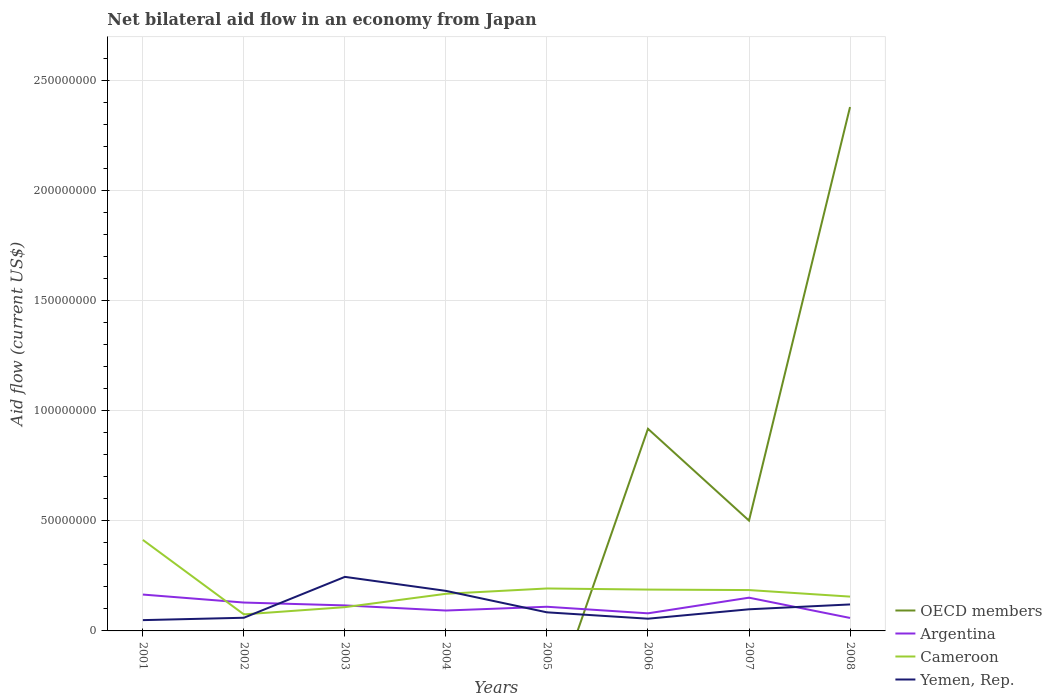How many different coloured lines are there?
Your answer should be very brief. 4. Does the line corresponding to Argentina intersect with the line corresponding to Cameroon?
Make the answer very short. Yes. Across all years, what is the maximum net bilateral aid flow in Cameroon?
Your answer should be compact. 7.51e+06. What is the total net bilateral aid flow in Yemen, Rep. in the graph?
Provide a succinct answer. 2.89e+06. What is the difference between the highest and the second highest net bilateral aid flow in Cameroon?
Your answer should be compact. 3.38e+07. What is the difference between the highest and the lowest net bilateral aid flow in Yemen, Rep.?
Offer a terse response. 3. How many lines are there?
Offer a terse response. 4. How many years are there in the graph?
Give a very brief answer. 8. What is the difference between two consecutive major ticks on the Y-axis?
Provide a short and direct response. 5.00e+07. Does the graph contain grids?
Make the answer very short. Yes. Where does the legend appear in the graph?
Offer a very short reply. Bottom right. How many legend labels are there?
Your response must be concise. 4. What is the title of the graph?
Keep it short and to the point. Net bilateral aid flow in an economy from Japan. What is the label or title of the X-axis?
Provide a succinct answer. Years. What is the label or title of the Y-axis?
Your answer should be compact. Aid flow (current US$). What is the Aid flow (current US$) of Argentina in 2001?
Your response must be concise. 1.65e+07. What is the Aid flow (current US$) in Cameroon in 2001?
Give a very brief answer. 4.13e+07. What is the Aid flow (current US$) of Yemen, Rep. in 2001?
Your answer should be very brief. 4.90e+06. What is the Aid flow (current US$) of Argentina in 2002?
Provide a succinct answer. 1.29e+07. What is the Aid flow (current US$) in Cameroon in 2002?
Make the answer very short. 7.51e+06. What is the Aid flow (current US$) of Yemen, Rep. in 2002?
Give a very brief answer. 5.98e+06. What is the Aid flow (current US$) in Argentina in 2003?
Provide a succinct answer. 1.16e+07. What is the Aid flow (current US$) of Cameroon in 2003?
Your response must be concise. 1.08e+07. What is the Aid flow (current US$) of Yemen, Rep. in 2003?
Your response must be concise. 2.45e+07. What is the Aid flow (current US$) of Argentina in 2004?
Your answer should be compact. 9.26e+06. What is the Aid flow (current US$) of Cameroon in 2004?
Keep it short and to the point. 1.69e+07. What is the Aid flow (current US$) of Yemen, Rep. in 2004?
Provide a succinct answer. 1.82e+07. What is the Aid flow (current US$) in Argentina in 2005?
Keep it short and to the point. 1.10e+07. What is the Aid flow (current US$) in Cameroon in 2005?
Provide a short and direct response. 1.93e+07. What is the Aid flow (current US$) of Yemen, Rep. in 2005?
Keep it short and to the point. 8.44e+06. What is the Aid flow (current US$) of OECD members in 2006?
Give a very brief answer. 9.18e+07. What is the Aid flow (current US$) in Argentina in 2006?
Your response must be concise. 7.99e+06. What is the Aid flow (current US$) of Cameroon in 2006?
Offer a very short reply. 1.88e+07. What is the Aid flow (current US$) in Yemen, Rep. in 2006?
Your response must be concise. 5.55e+06. What is the Aid flow (current US$) in OECD members in 2007?
Offer a terse response. 5.01e+07. What is the Aid flow (current US$) of Argentina in 2007?
Offer a terse response. 1.51e+07. What is the Aid flow (current US$) in Cameroon in 2007?
Ensure brevity in your answer.  1.86e+07. What is the Aid flow (current US$) of Yemen, Rep. in 2007?
Your response must be concise. 9.82e+06. What is the Aid flow (current US$) in OECD members in 2008?
Make the answer very short. 2.38e+08. What is the Aid flow (current US$) in Argentina in 2008?
Your answer should be compact. 5.89e+06. What is the Aid flow (current US$) of Cameroon in 2008?
Offer a terse response. 1.56e+07. What is the Aid flow (current US$) of Yemen, Rep. in 2008?
Keep it short and to the point. 1.20e+07. Across all years, what is the maximum Aid flow (current US$) of OECD members?
Your answer should be compact. 2.38e+08. Across all years, what is the maximum Aid flow (current US$) of Argentina?
Offer a very short reply. 1.65e+07. Across all years, what is the maximum Aid flow (current US$) in Cameroon?
Your response must be concise. 4.13e+07. Across all years, what is the maximum Aid flow (current US$) in Yemen, Rep.?
Make the answer very short. 2.45e+07. Across all years, what is the minimum Aid flow (current US$) of Argentina?
Give a very brief answer. 5.89e+06. Across all years, what is the minimum Aid flow (current US$) in Cameroon?
Your response must be concise. 7.51e+06. Across all years, what is the minimum Aid flow (current US$) in Yemen, Rep.?
Your answer should be compact. 4.90e+06. What is the total Aid flow (current US$) of OECD members in the graph?
Offer a very short reply. 3.80e+08. What is the total Aid flow (current US$) of Argentina in the graph?
Your answer should be compact. 9.02e+07. What is the total Aid flow (current US$) of Cameroon in the graph?
Offer a very short reply. 1.49e+08. What is the total Aid flow (current US$) in Yemen, Rep. in the graph?
Your answer should be compact. 8.94e+07. What is the difference between the Aid flow (current US$) in Argentina in 2001 and that in 2002?
Give a very brief answer. 3.63e+06. What is the difference between the Aid flow (current US$) in Cameroon in 2001 and that in 2002?
Your answer should be very brief. 3.38e+07. What is the difference between the Aid flow (current US$) of Yemen, Rep. in 2001 and that in 2002?
Your response must be concise. -1.08e+06. What is the difference between the Aid flow (current US$) in Argentina in 2001 and that in 2003?
Your answer should be compact. 4.93e+06. What is the difference between the Aid flow (current US$) in Cameroon in 2001 and that in 2003?
Provide a short and direct response. 3.05e+07. What is the difference between the Aid flow (current US$) of Yemen, Rep. in 2001 and that in 2003?
Provide a succinct answer. -1.96e+07. What is the difference between the Aid flow (current US$) of Argentina in 2001 and that in 2004?
Offer a terse response. 7.25e+06. What is the difference between the Aid flow (current US$) in Cameroon in 2001 and that in 2004?
Offer a very short reply. 2.45e+07. What is the difference between the Aid flow (current US$) in Yemen, Rep. in 2001 and that in 2004?
Offer a very short reply. -1.33e+07. What is the difference between the Aid flow (current US$) of Argentina in 2001 and that in 2005?
Make the answer very short. 5.54e+06. What is the difference between the Aid flow (current US$) in Cameroon in 2001 and that in 2005?
Provide a short and direct response. 2.20e+07. What is the difference between the Aid flow (current US$) in Yemen, Rep. in 2001 and that in 2005?
Offer a terse response. -3.54e+06. What is the difference between the Aid flow (current US$) of Argentina in 2001 and that in 2006?
Keep it short and to the point. 8.52e+06. What is the difference between the Aid flow (current US$) of Cameroon in 2001 and that in 2006?
Give a very brief answer. 2.26e+07. What is the difference between the Aid flow (current US$) of Yemen, Rep. in 2001 and that in 2006?
Your answer should be compact. -6.50e+05. What is the difference between the Aid flow (current US$) in Argentina in 2001 and that in 2007?
Ensure brevity in your answer.  1.42e+06. What is the difference between the Aid flow (current US$) of Cameroon in 2001 and that in 2007?
Keep it short and to the point. 2.28e+07. What is the difference between the Aid flow (current US$) in Yemen, Rep. in 2001 and that in 2007?
Offer a terse response. -4.92e+06. What is the difference between the Aid flow (current US$) in Argentina in 2001 and that in 2008?
Provide a succinct answer. 1.06e+07. What is the difference between the Aid flow (current US$) in Cameroon in 2001 and that in 2008?
Your answer should be compact. 2.57e+07. What is the difference between the Aid flow (current US$) of Yemen, Rep. in 2001 and that in 2008?
Ensure brevity in your answer.  -7.12e+06. What is the difference between the Aid flow (current US$) in Argentina in 2002 and that in 2003?
Offer a terse response. 1.30e+06. What is the difference between the Aid flow (current US$) in Cameroon in 2002 and that in 2003?
Make the answer very short. -3.28e+06. What is the difference between the Aid flow (current US$) in Yemen, Rep. in 2002 and that in 2003?
Keep it short and to the point. -1.86e+07. What is the difference between the Aid flow (current US$) in Argentina in 2002 and that in 2004?
Your answer should be compact. 3.62e+06. What is the difference between the Aid flow (current US$) in Cameroon in 2002 and that in 2004?
Keep it short and to the point. -9.35e+06. What is the difference between the Aid flow (current US$) of Yemen, Rep. in 2002 and that in 2004?
Ensure brevity in your answer.  -1.22e+07. What is the difference between the Aid flow (current US$) of Argentina in 2002 and that in 2005?
Give a very brief answer. 1.91e+06. What is the difference between the Aid flow (current US$) of Cameroon in 2002 and that in 2005?
Ensure brevity in your answer.  -1.18e+07. What is the difference between the Aid flow (current US$) of Yemen, Rep. in 2002 and that in 2005?
Your answer should be compact. -2.46e+06. What is the difference between the Aid flow (current US$) in Argentina in 2002 and that in 2006?
Provide a short and direct response. 4.89e+06. What is the difference between the Aid flow (current US$) of Cameroon in 2002 and that in 2006?
Keep it short and to the point. -1.13e+07. What is the difference between the Aid flow (current US$) of Yemen, Rep. in 2002 and that in 2006?
Your answer should be very brief. 4.30e+05. What is the difference between the Aid flow (current US$) of Argentina in 2002 and that in 2007?
Make the answer very short. -2.21e+06. What is the difference between the Aid flow (current US$) of Cameroon in 2002 and that in 2007?
Offer a terse response. -1.10e+07. What is the difference between the Aid flow (current US$) of Yemen, Rep. in 2002 and that in 2007?
Provide a short and direct response. -3.84e+06. What is the difference between the Aid flow (current US$) of Argentina in 2002 and that in 2008?
Make the answer very short. 6.99e+06. What is the difference between the Aid flow (current US$) of Cameroon in 2002 and that in 2008?
Give a very brief answer. -8.07e+06. What is the difference between the Aid flow (current US$) in Yemen, Rep. in 2002 and that in 2008?
Give a very brief answer. -6.04e+06. What is the difference between the Aid flow (current US$) in Argentina in 2003 and that in 2004?
Provide a succinct answer. 2.32e+06. What is the difference between the Aid flow (current US$) in Cameroon in 2003 and that in 2004?
Your answer should be very brief. -6.07e+06. What is the difference between the Aid flow (current US$) in Yemen, Rep. in 2003 and that in 2004?
Offer a very short reply. 6.36e+06. What is the difference between the Aid flow (current US$) in Argentina in 2003 and that in 2005?
Keep it short and to the point. 6.10e+05. What is the difference between the Aid flow (current US$) of Cameroon in 2003 and that in 2005?
Provide a short and direct response. -8.48e+06. What is the difference between the Aid flow (current US$) in Yemen, Rep. in 2003 and that in 2005?
Your answer should be compact. 1.61e+07. What is the difference between the Aid flow (current US$) of Argentina in 2003 and that in 2006?
Your response must be concise. 3.59e+06. What is the difference between the Aid flow (current US$) of Cameroon in 2003 and that in 2006?
Your response must be concise. -7.98e+06. What is the difference between the Aid flow (current US$) in Yemen, Rep. in 2003 and that in 2006?
Your response must be concise. 1.90e+07. What is the difference between the Aid flow (current US$) of Argentina in 2003 and that in 2007?
Offer a terse response. -3.51e+06. What is the difference between the Aid flow (current US$) in Cameroon in 2003 and that in 2007?
Provide a succinct answer. -7.76e+06. What is the difference between the Aid flow (current US$) of Yemen, Rep. in 2003 and that in 2007?
Offer a very short reply. 1.47e+07. What is the difference between the Aid flow (current US$) of Argentina in 2003 and that in 2008?
Offer a terse response. 5.69e+06. What is the difference between the Aid flow (current US$) in Cameroon in 2003 and that in 2008?
Your response must be concise. -4.79e+06. What is the difference between the Aid flow (current US$) of Yemen, Rep. in 2003 and that in 2008?
Ensure brevity in your answer.  1.25e+07. What is the difference between the Aid flow (current US$) of Argentina in 2004 and that in 2005?
Provide a short and direct response. -1.71e+06. What is the difference between the Aid flow (current US$) of Cameroon in 2004 and that in 2005?
Your answer should be compact. -2.41e+06. What is the difference between the Aid flow (current US$) of Yemen, Rep. in 2004 and that in 2005?
Ensure brevity in your answer.  9.74e+06. What is the difference between the Aid flow (current US$) in Argentina in 2004 and that in 2006?
Offer a terse response. 1.27e+06. What is the difference between the Aid flow (current US$) of Cameroon in 2004 and that in 2006?
Make the answer very short. -1.91e+06. What is the difference between the Aid flow (current US$) of Yemen, Rep. in 2004 and that in 2006?
Keep it short and to the point. 1.26e+07. What is the difference between the Aid flow (current US$) in Argentina in 2004 and that in 2007?
Your response must be concise. -5.83e+06. What is the difference between the Aid flow (current US$) of Cameroon in 2004 and that in 2007?
Make the answer very short. -1.69e+06. What is the difference between the Aid flow (current US$) in Yemen, Rep. in 2004 and that in 2007?
Give a very brief answer. 8.36e+06. What is the difference between the Aid flow (current US$) of Argentina in 2004 and that in 2008?
Offer a very short reply. 3.37e+06. What is the difference between the Aid flow (current US$) of Cameroon in 2004 and that in 2008?
Make the answer very short. 1.28e+06. What is the difference between the Aid flow (current US$) in Yemen, Rep. in 2004 and that in 2008?
Offer a very short reply. 6.16e+06. What is the difference between the Aid flow (current US$) of Argentina in 2005 and that in 2006?
Your response must be concise. 2.98e+06. What is the difference between the Aid flow (current US$) in Yemen, Rep. in 2005 and that in 2006?
Offer a very short reply. 2.89e+06. What is the difference between the Aid flow (current US$) of Argentina in 2005 and that in 2007?
Make the answer very short. -4.12e+06. What is the difference between the Aid flow (current US$) of Cameroon in 2005 and that in 2007?
Ensure brevity in your answer.  7.20e+05. What is the difference between the Aid flow (current US$) in Yemen, Rep. in 2005 and that in 2007?
Offer a very short reply. -1.38e+06. What is the difference between the Aid flow (current US$) in Argentina in 2005 and that in 2008?
Make the answer very short. 5.08e+06. What is the difference between the Aid flow (current US$) of Cameroon in 2005 and that in 2008?
Your response must be concise. 3.69e+06. What is the difference between the Aid flow (current US$) in Yemen, Rep. in 2005 and that in 2008?
Make the answer very short. -3.58e+06. What is the difference between the Aid flow (current US$) of OECD members in 2006 and that in 2007?
Ensure brevity in your answer.  4.17e+07. What is the difference between the Aid flow (current US$) in Argentina in 2006 and that in 2007?
Ensure brevity in your answer.  -7.10e+06. What is the difference between the Aid flow (current US$) of Cameroon in 2006 and that in 2007?
Make the answer very short. 2.20e+05. What is the difference between the Aid flow (current US$) in Yemen, Rep. in 2006 and that in 2007?
Make the answer very short. -4.27e+06. What is the difference between the Aid flow (current US$) of OECD members in 2006 and that in 2008?
Give a very brief answer. -1.46e+08. What is the difference between the Aid flow (current US$) of Argentina in 2006 and that in 2008?
Your answer should be very brief. 2.10e+06. What is the difference between the Aid flow (current US$) in Cameroon in 2006 and that in 2008?
Your response must be concise. 3.19e+06. What is the difference between the Aid flow (current US$) of Yemen, Rep. in 2006 and that in 2008?
Your answer should be very brief. -6.47e+06. What is the difference between the Aid flow (current US$) of OECD members in 2007 and that in 2008?
Offer a very short reply. -1.88e+08. What is the difference between the Aid flow (current US$) of Argentina in 2007 and that in 2008?
Provide a succinct answer. 9.20e+06. What is the difference between the Aid flow (current US$) in Cameroon in 2007 and that in 2008?
Offer a very short reply. 2.97e+06. What is the difference between the Aid flow (current US$) in Yemen, Rep. in 2007 and that in 2008?
Provide a succinct answer. -2.20e+06. What is the difference between the Aid flow (current US$) in Argentina in 2001 and the Aid flow (current US$) in Cameroon in 2002?
Offer a very short reply. 9.00e+06. What is the difference between the Aid flow (current US$) of Argentina in 2001 and the Aid flow (current US$) of Yemen, Rep. in 2002?
Your response must be concise. 1.05e+07. What is the difference between the Aid flow (current US$) of Cameroon in 2001 and the Aid flow (current US$) of Yemen, Rep. in 2002?
Offer a terse response. 3.53e+07. What is the difference between the Aid flow (current US$) of Argentina in 2001 and the Aid flow (current US$) of Cameroon in 2003?
Ensure brevity in your answer.  5.72e+06. What is the difference between the Aid flow (current US$) in Argentina in 2001 and the Aid flow (current US$) in Yemen, Rep. in 2003?
Keep it short and to the point. -8.03e+06. What is the difference between the Aid flow (current US$) of Cameroon in 2001 and the Aid flow (current US$) of Yemen, Rep. in 2003?
Your response must be concise. 1.68e+07. What is the difference between the Aid flow (current US$) in Argentina in 2001 and the Aid flow (current US$) in Cameroon in 2004?
Offer a very short reply. -3.50e+05. What is the difference between the Aid flow (current US$) in Argentina in 2001 and the Aid flow (current US$) in Yemen, Rep. in 2004?
Your response must be concise. -1.67e+06. What is the difference between the Aid flow (current US$) of Cameroon in 2001 and the Aid flow (current US$) of Yemen, Rep. in 2004?
Your answer should be very brief. 2.31e+07. What is the difference between the Aid flow (current US$) in Argentina in 2001 and the Aid flow (current US$) in Cameroon in 2005?
Your response must be concise. -2.76e+06. What is the difference between the Aid flow (current US$) in Argentina in 2001 and the Aid flow (current US$) in Yemen, Rep. in 2005?
Offer a terse response. 8.07e+06. What is the difference between the Aid flow (current US$) of Cameroon in 2001 and the Aid flow (current US$) of Yemen, Rep. in 2005?
Your response must be concise. 3.29e+07. What is the difference between the Aid flow (current US$) in Argentina in 2001 and the Aid flow (current US$) in Cameroon in 2006?
Ensure brevity in your answer.  -2.26e+06. What is the difference between the Aid flow (current US$) of Argentina in 2001 and the Aid flow (current US$) of Yemen, Rep. in 2006?
Ensure brevity in your answer.  1.10e+07. What is the difference between the Aid flow (current US$) of Cameroon in 2001 and the Aid flow (current US$) of Yemen, Rep. in 2006?
Offer a very short reply. 3.58e+07. What is the difference between the Aid flow (current US$) of Argentina in 2001 and the Aid flow (current US$) of Cameroon in 2007?
Give a very brief answer. -2.04e+06. What is the difference between the Aid flow (current US$) of Argentina in 2001 and the Aid flow (current US$) of Yemen, Rep. in 2007?
Offer a terse response. 6.69e+06. What is the difference between the Aid flow (current US$) in Cameroon in 2001 and the Aid flow (current US$) in Yemen, Rep. in 2007?
Offer a terse response. 3.15e+07. What is the difference between the Aid flow (current US$) in Argentina in 2001 and the Aid flow (current US$) in Cameroon in 2008?
Provide a short and direct response. 9.30e+05. What is the difference between the Aid flow (current US$) of Argentina in 2001 and the Aid flow (current US$) of Yemen, Rep. in 2008?
Provide a succinct answer. 4.49e+06. What is the difference between the Aid flow (current US$) of Cameroon in 2001 and the Aid flow (current US$) of Yemen, Rep. in 2008?
Your response must be concise. 2.93e+07. What is the difference between the Aid flow (current US$) in Argentina in 2002 and the Aid flow (current US$) in Cameroon in 2003?
Give a very brief answer. 2.09e+06. What is the difference between the Aid flow (current US$) of Argentina in 2002 and the Aid flow (current US$) of Yemen, Rep. in 2003?
Provide a succinct answer. -1.17e+07. What is the difference between the Aid flow (current US$) in Cameroon in 2002 and the Aid flow (current US$) in Yemen, Rep. in 2003?
Provide a succinct answer. -1.70e+07. What is the difference between the Aid flow (current US$) in Argentina in 2002 and the Aid flow (current US$) in Cameroon in 2004?
Your response must be concise. -3.98e+06. What is the difference between the Aid flow (current US$) of Argentina in 2002 and the Aid flow (current US$) of Yemen, Rep. in 2004?
Ensure brevity in your answer.  -5.30e+06. What is the difference between the Aid flow (current US$) of Cameroon in 2002 and the Aid flow (current US$) of Yemen, Rep. in 2004?
Provide a succinct answer. -1.07e+07. What is the difference between the Aid flow (current US$) in Argentina in 2002 and the Aid flow (current US$) in Cameroon in 2005?
Your response must be concise. -6.39e+06. What is the difference between the Aid flow (current US$) of Argentina in 2002 and the Aid flow (current US$) of Yemen, Rep. in 2005?
Offer a terse response. 4.44e+06. What is the difference between the Aid flow (current US$) of Cameroon in 2002 and the Aid flow (current US$) of Yemen, Rep. in 2005?
Ensure brevity in your answer.  -9.30e+05. What is the difference between the Aid flow (current US$) of Argentina in 2002 and the Aid flow (current US$) of Cameroon in 2006?
Your answer should be very brief. -5.89e+06. What is the difference between the Aid flow (current US$) in Argentina in 2002 and the Aid flow (current US$) in Yemen, Rep. in 2006?
Provide a succinct answer. 7.33e+06. What is the difference between the Aid flow (current US$) of Cameroon in 2002 and the Aid flow (current US$) of Yemen, Rep. in 2006?
Make the answer very short. 1.96e+06. What is the difference between the Aid flow (current US$) in Argentina in 2002 and the Aid flow (current US$) in Cameroon in 2007?
Provide a short and direct response. -5.67e+06. What is the difference between the Aid flow (current US$) in Argentina in 2002 and the Aid flow (current US$) in Yemen, Rep. in 2007?
Offer a terse response. 3.06e+06. What is the difference between the Aid flow (current US$) in Cameroon in 2002 and the Aid flow (current US$) in Yemen, Rep. in 2007?
Ensure brevity in your answer.  -2.31e+06. What is the difference between the Aid flow (current US$) of Argentina in 2002 and the Aid flow (current US$) of Cameroon in 2008?
Give a very brief answer. -2.70e+06. What is the difference between the Aid flow (current US$) of Argentina in 2002 and the Aid flow (current US$) of Yemen, Rep. in 2008?
Give a very brief answer. 8.60e+05. What is the difference between the Aid flow (current US$) in Cameroon in 2002 and the Aid flow (current US$) in Yemen, Rep. in 2008?
Provide a short and direct response. -4.51e+06. What is the difference between the Aid flow (current US$) of Argentina in 2003 and the Aid flow (current US$) of Cameroon in 2004?
Provide a short and direct response. -5.28e+06. What is the difference between the Aid flow (current US$) of Argentina in 2003 and the Aid flow (current US$) of Yemen, Rep. in 2004?
Provide a short and direct response. -6.60e+06. What is the difference between the Aid flow (current US$) in Cameroon in 2003 and the Aid flow (current US$) in Yemen, Rep. in 2004?
Provide a succinct answer. -7.39e+06. What is the difference between the Aid flow (current US$) of Argentina in 2003 and the Aid flow (current US$) of Cameroon in 2005?
Make the answer very short. -7.69e+06. What is the difference between the Aid flow (current US$) in Argentina in 2003 and the Aid flow (current US$) in Yemen, Rep. in 2005?
Ensure brevity in your answer.  3.14e+06. What is the difference between the Aid flow (current US$) in Cameroon in 2003 and the Aid flow (current US$) in Yemen, Rep. in 2005?
Your answer should be very brief. 2.35e+06. What is the difference between the Aid flow (current US$) in Argentina in 2003 and the Aid flow (current US$) in Cameroon in 2006?
Ensure brevity in your answer.  -7.19e+06. What is the difference between the Aid flow (current US$) in Argentina in 2003 and the Aid flow (current US$) in Yemen, Rep. in 2006?
Give a very brief answer. 6.03e+06. What is the difference between the Aid flow (current US$) in Cameroon in 2003 and the Aid flow (current US$) in Yemen, Rep. in 2006?
Ensure brevity in your answer.  5.24e+06. What is the difference between the Aid flow (current US$) of Argentina in 2003 and the Aid flow (current US$) of Cameroon in 2007?
Ensure brevity in your answer.  -6.97e+06. What is the difference between the Aid flow (current US$) in Argentina in 2003 and the Aid flow (current US$) in Yemen, Rep. in 2007?
Ensure brevity in your answer.  1.76e+06. What is the difference between the Aid flow (current US$) in Cameroon in 2003 and the Aid flow (current US$) in Yemen, Rep. in 2007?
Offer a very short reply. 9.70e+05. What is the difference between the Aid flow (current US$) in Argentina in 2003 and the Aid flow (current US$) in Cameroon in 2008?
Provide a short and direct response. -4.00e+06. What is the difference between the Aid flow (current US$) in Argentina in 2003 and the Aid flow (current US$) in Yemen, Rep. in 2008?
Provide a short and direct response. -4.40e+05. What is the difference between the Aid flow (current US$) of Cameroon in 2003 and the Aid flow (current US$) of Yemen, Rep. in 2008?
Ensure brevity in your answer.  -1.23e+06. What is the difference between the Aid flow (current US$) of Argentina in 2004 and the Aid flow (current US$) of Cameroon in 2005?
Your response must be concise. -1.00e+07. What is the difference between the Aid flow (current US$) in Argentina in 2004 and the Aid flow (current US$) in Yemen, Rep. in 2005?
Ensure brevity in your answer.  8.20e+05. What is the difference between the Aid flow (current US$) in Cameroon in 2004 and the Aid flow (current US$) in Yemen, Rep. in 2005?
Your answer should be compact. 8.42e+06. What is the difference between the Aid flow (current US$) in Argentina in 2004 and the Aid flow (current US$) in Cameroon in 2006?
Offer a very short reply. -9.51e+06. What is the difference between the Aid flow (current US$) of Argentina in 2004 and the Aid flow (current US$) of Yemen, Rep. in 2006?
Your answer should be compact. 3.71e+06. What is the difference between the Aid flow (current US$) in Cameroon in 2004 and the Aid flow (current US$) in Yemen, Rep. in 2006?
Offer a very short reply. 1.13e+07. What is the difference between the Aid flow (current US$) of Argentina in 2004 and the Aid flow (current US$) of Cameroon in 2007?
Offer a very short reply. -9.29e+06. What is the difference between the Aid flow (current US$) in Argentina in 2004 and the Aid flow (current US$) in Yemen, Rep. in 2007?
Your answer should be very brief. -5.60e+05. What is the difference between the Aid flow (current US$) of Cameroon in 2004 and the Aid flow (current US$) of Yemen, Rep. in 2007?
Give a very brief answer. 7.04e+06. What is the difference between the Aid flow (current US$) in Argentina in 2004 and the Aid flow (current US$) in Cameroon in 2008?
Your answer should be very brief. -6.32e+06. What is the difference between the Aid flow (current US$) of Argentina in 2004 and the Aid flow (current US$) of Yemen, Rep. in 2008?
Provide a short and direct response. -2.76e+06. What is the difference between the Aid flow (current US$) in Cameroon in 2004 and the Aid flow (current US$) in Yemen, Rep. in 2008?
Ensure brevity in your answer.  4.84e+06. What is the difference between the Aid flow (current US$) of Argentina in 2005 and the Aid flow (current US$) of Cameroon in 2006?
Your answer should be very brief. -7.80e+06. What is the difference between the Aid flow (current US$) of Argentina in 2005 and the Aid flow (current US$) of Yemen, Rep. in 2006?
Provide a succinct answer. 5.42e+06. What is the difference between the Aid flow (current US$) in Cameroon in 2005 and the Aid flow (current US$) in Yemen, Rep. in 2006?
Ensure brevity in your answer.  1.37e+07. What is the difference between the Aid flow (current US$) in Argentina in 2005 and the Aid flow (current US$) in Cameroon in 2007?
Provide a succinct answer. -7.58e+06. What is the difference between the Aid flow (current US$) of Argentina in 2005 and the Aid flow (current US$) of Yemen, Rep. in 2007?
Offer a very short reply. 1.15e+06. What is the difference between the Aid flow (current US$) of Cameroon in 2005 and the Aid flow (current US$) of Yemen, Rep. in 2007?
Your answer should be very brief. 9.45e+06. What is the difference between the Aid flow (current US$) in Argentina in 2005 and the Aid flow (current US$) in Cameroon in 2008?
Make the answer very short. -4.61e+06. What is the difference between the Aid flow (current US$) of Argentina in 2005 and the Aid flow (current US$) of Yemen, Rep. in 2008?
Give a very brief answer. -1.05e+06. What is the difference between the Aid flow (current US$) of Cameroon in 2005 and the Aid flow (current US$) of Yemen, Rep. in 2008?
Offer a very short reply. 7.25e+06. What is the difference between the Aid flow (current US$) in OECD members in 2006 and the Aid flow (current US$) in Argentina in 2007?
Provide a short and direct response. 7.67e+07. What is the difference between the Aid flow (current US$) of OECD members in 2006 and the Aid flow (current US$) of Cameroon in 2007?
Give a very brief answer. 7.32e+07. What is the difference between the Aid flow (current US$) of OECD members in 2006 and the Aid flow (current US$) of Yemen, Rep. in 2007?
Your response must be concise. 8.19e+07. What is the difference between the Aid flow (current US$) of Argentina in 2006 and the Aid flow (current US$) of Cameroon in 2007?
Offer a very short reply. -1.06e+07. What is the difference between the Aid flow (current US$) in Argentina in 2006 and the Aid flow (current US$) in Yemen, Rep. in 2007?
Give a very brief answer. -1.83e+06. What is the difference between the Aid flow (current US$) in Cameroon in 2006 and the Aid flow (current US$) in Yemen, Rep. in 2007?
Keep it short and to the point. 8.95e+06. What is the difference between the Aid flow (current US$) in OECD members in 2006 and the Aid flow (current US$) in Argentina in 2008?
Make the answer very short. 8.59e+07. What is the difference between the Aid flow (current US$) in OECD members in 2006 and the Aid flow (current US$) in Cameroon in 2008?
Ensure brevity in your answer.  7.62e+07. What is the difference between the Aid flow (current US$) of OECD members in 2006 and the Aid flow (current US$) of Yemen, Rep. in 2008?
Give a very brief answer. 7.97e+07. What is the difference between the Aid flow (current US$) of Argentina in 2006 and the Aid flow (current US$) of Cameroon in 2008?
Give a very brief answer. -7.59e+06. What is the difference between the Aid flow (current US$) of Argentina in 2006 and the Aid flow (current US$) of Yemen, Rep. in 2008?
Your answer should be compact. -4.03e+06. What is the difference between the Aid flow (current US$) in Cameroon in 2006 and the Aid flow (current US$) in Yemen, Rep. in 2008?
Make the answer very short. 6.75e+06. What is the difference between the Aid flow (current US$) in OECD members in 2007 and the Aid flow (current US$) in Argentina in 2008?
Give a very brief answer. 4.42e+07. What is the difference between the Aid flow (current US$) of OECD members in 2007 and the Aid flow (current US$) of Cameroon in 2008?
Give a very brief answer. 3.45e+07. What is the difference between the Aid flow (current US$) in OECD members in 2007 and the Aid flow (current US$) in Yemen, Rep. in 2008?
Make the answer very short. 3.81e+07. What is the difference between the Aid flow (current US$) in Argentina in 2007 and the Aid flow (current US$) in Cameroon in 2008?
Make the answer very short. -4.90e+05. What is the difference between the Aid flow (current US$) of Argentina in 2007 and the Aid flow (current US$) of Yemen, Rep. in 2008?
Provide a short and direct response. 3.07e+06. What is the difference between the Aid flow (current US$) in Cameroon in 2007 and the Aid flow (current US$) in Yemen, Rep. in 2008?
Provide a short and direct response. 6.53e+06. What is the average Aid flow (current US$) of OECD members per year?
Your answer should be very brief. 4.75e+07. What is the average Aid flow (current US$) in Argentina per year?
Your answer should be compact. 1.13e+07. What is the average Aid flow (current US$) of Cameroon per year?
Offer a very short reply. 1.86e+07. What is the average Aid flow (current US$) of Yemen, Rep. per year?
Give a very brief answer. 1.12e+07. In the year 2001, what is the difference between the Aid flow (current US$) of Argentina and Aid flow (current US$) of Cameroon?
Offer a very short reply. -2.48e+07. In the year 2001, what is the difference between the Aid flow (current US$) of Argentina and Aid flow (current US$) of Yemen, Rep.?
Your response must be concise. 1.16e+07. In the year 2001, what is the difference between the Aid flow (current US$) in Cameroon and Aid flow (current US$) in Yemen, Rep.?
Ensure brevity in your answer.  3.64e+07. In the year 2002, what is the difference between the Aid flow (current US$) of Argentina and Aid flow (current US$) of Cameroon?
Make the answer very short. 5.37e+06. In the year 2002, what is the difference between the Aid flow (current US$) of Argentina and Aid flow (current US$) of Yemen, Rep.?
Offer a very short reply. 6.90e+06. In the year 2002, what is the difference between the Aid flow (current US$) in Cameroon and Aid flow (current US$) in Yemen, Rep.?
Offer a terse response. 1.53e+06. In the year 2003, what is the difference between the Aid flow (current US$) of Argentina and Aid flow (current US$) of Cameroon?
Provide a short and direct response. 7.90e+05. In the year 2003, what is the difference between the Aid flow (current US$) of Argentina and Aid flow (current US$) of Yemen, Rep.?
Provide a short and direct response. -1.30e+07. In the year 2003, what is the difference between the Aid flow (current US$) of Cameroon and Aid flow (current US$) of Yemen, Rep.?
Keep it short and to the point. -1.38e+07. In the year 2004, what is the difference between the Aid flow (current US$) of Argentina and Aid flow (current US$) of Cameroon?
Provide a short and direct response. -7.60e+06. In the year 2004, what is the difference between the Aid flow (current US$) of Argentina and Aid flow (current US$) of Yemen, Rep.?
Provide a short and direct response. -8.92e+06. In the year 2004, what is the difference between the Aid flow (current US$) of Cameroon and Aid flow (current US$) of Yemen, Rep.?
Offer a very short reply. -1.32e+06. In the year 2005, what is the difference between the Aid flow (current US$) of Argentina and Aid flow (current US$) of Cameroon?
Keep it short and to the point. -8.30e+06. In the year 2005, what is the difference between the Aid flow (current US$) in Argentina and Aid flow (current US$) in Yemen, Rep.?
Provide a succinct answer. 2.53e+06. In the year 2005, what is the difference between the Aid flow (current US$) in Cameroon and Aid flow (current US$) in Yemen, Rep.?
Offer a very short reply. 1.08e+07. In the year 2006, what is the difference between the Aid flow (current US$) of OECD members and Aid flow (current US$) of Argentina?
Your response must be concise. 8.38e+07. In the year 2006, what is the difference between the Aid flow (current US$) of OECD members and Aid flow (current US$) of Cameroon?
Your response must be concise. 7.30e+07. In the year 2006, what is the difference between the Aid flow (current US$) in OECD members and Aid flow (current US$) in Yemen, Rep.?
Your response must be concise. 8.62e+07. In the year 2006, what is the difference between the Aid flow (current US$) of Argentina and Aid flow (current US$) of Cameroon?
Give a very brief answer. -1.08e+07. In the year 2006, what is the difference between the Aid flow (current US$) of Argentina and Aid flow (current US$) of Yemen, Rep.?
Your response must be concise. 2.44e+06. In the year 2006, what is the difference between the Aid flow (current US$) in Cameroon and Aid flow (current US$) in Yemen, Rep.?
Your answer should be very brief. 1.32e+07. In the year 2007, what is the difference between the Aid flow (current US$) in OECD members and Aid flow (current US$) in Argentina?
Make the answer very short. 3.50e+07. In the year 2007, what is the difference between the Aid flow (current US$) of OECD members and Aid flow (current US$) of Cameroon?
Make the answer very short. 3.15e+07. In the year 2007, what is the difference between the Aid flow (current US$) in OECD members and Aid flow (current US$) in Yemen, Rep.?
Provide a short and direct response. 4.03e+07. In the year 2007, what is the difference between the Aid flow (current US$) in Argentina and Aid flow (current US$) in Cameroon?
Make the answer very short. -3.46e+06. In the year 2007, what is the difference between the Aid flow (current US$) in Argentina and Aid flow (current US$) in Yemen, Rep.?
Offer a terse response. 5.27e+06. In the year 2007, what is the difference between the Aid flow (current US$) of Cameroon and Aid flow (current US$) of Yemen, Rep.?
Offer a terse response. 8.73e+06. In the year 2008, what is the difference between the Aid flow (current US$) in OECD members and Aid flow (current US$) in Argentina?
Give a very brief answer. 2.32e+08. In the year 2008, what is the difference between the Aid flow (current US$) of OECD members and Aid flow (current US$) of Cameroon?
Offer a very short reply. 2.22e+08. In the year 2008, what is the difference between the Aid flow (current US$) of OECD members and Aid flow (current US$) of Yemen, Rep.?
Provide a succinct answer. 2.26e+08. In the year 2008, what is the difference between the Aid flow (current US$) in Argentina and Aid flow (current US$) in Cameroon?
Your answer should be very brief. -9.69e+06. In the year 2008, what is the difference between the Aid flow (current US$) of Argentina and Aid flow (current US$) of Yemen, Rep.?
Your response must be concise. -6.13e+06. In the year 2008, what is the difference between the Aid flow (current US$) in Cameroon and Aid flow (current US$) in Yemen, Rep.?
Your response must be concise. 3.56e+06. What is the ratio of the Aid flow (current US$) of Argentina in 2001 to that in 2002?
Offer a very short reply. 1.28. What is the ratio of the Aid flow (current US$) in Cameroon in 2001 to that in 2002?
Make the answer very short. 5.5. What is the ratio of the Aid flow (current US$) in Yemen, Rep. in 2001 to that in 2002?
Offer a very short reply. 0.82. What is the ratio of the Aid flow (current US$) of Argentina in 2001 to that in 2003?
Your answer should be compact. 1.43. What is the ratio of the Aid flow (current US$) in Cameroon in 2001 to that in 2003?
Make the answer very short. 3.83. What is the ratio of the Aid flow (current US$) in Yemen, Rep. in 2001 to that in 2003?
Make the answer very short. 0.2. What is the ratio of the Aid flow (current US$) in Argentina in 2001 to that in 2004?
Offer a very short reply. 1.78. What is the ratio of the Aid flow (current US$) of Cameroon in 2001 to that in 2004?
Your answer should be very brief. 2.45. What is the ratio of the Aid flow (current US$) of Yemen, Rep. in 2001 to that in 2004?
Offer a very short reply. 0.27. What is the ratio of the Aid flow (current US$) of Argentina in 2001 to that in 2005?
Your response must be concise. 1.5. What is the ratio of the Aid flow (current US$) in Cameroon in 2001 to that in 2005?
Offer a terse response. 2.14. What is the ratio of the Aid flow (current US$) of Yemen, Rep. in 2001 to that in 2005?
Provide a succinct answer. 0.58. What is the ratio of the Aid flow (current US$) in Argentina in 2001 to that in 2006?
Provide a short and direct response. 2.07. What is the ratio of the Aid flow (current US$) in Cameroon in 2001 to that in 2006?
Your answer should be compact. 2.2. What is the ratio of the Aid flow (current US$) of Yemen, Rep. in 2001 to that in 2006?
Your answer should be compact. 0.88. What is the ratio of the Aid flow (current US$) of Argentina in 2001 to that in 2007?
Make the answer very short. 1.09. What is the ratio of the Aid flow (current US$) of Cameroon in 2001 to that in 2007?
Give a very brief answer. 2.23. What is the ratio of the Aid flow (current US$) of Yemen, Rep. in 2001 to that in 2007?
Your answer should be very brief. 0.5. What is the ratio of the Aid flow (current US$) in Argentina in 2001 to that in 2008?
Offer a very short reply. 2.8. What is the ratio of the Aid flow (current US$) in Cameroon in 2001 to that in 2008?
Make the answer very short. 2.65. What is the ratio of the Aid flow (current US$) of Yemen, Rep. in 2001 to that in 2008?
Offer a very short reply. 0.41. What is the ratio of the Aid flow (current US$) of Argentina in 2002 to that in 2003?
Offer a terse response. 1.11. What is the ratio of the Aid flow (current US$) of Cameroon in 2002 to that in 2003?
Your response must be concise. 0.7. What is the ratio of the Aid flow (current US$) in Yemen, Rep. in 2002 to that in 2003?
Keep it short and to the point. 0.24. What is the ratio of the Aid flow (current US$) of Argentina in 2002 to that in 2004?
Your answer should be very brief. 1.39. What is the ratio of the Aid flow (current US$) of Cameroon in 2002 to that in 2004?
Your answer should be very brief. 0.45. What is the ratio of the Aid flow (current US$) of Yemen, Rep. in 2002 to that in 2004?
Offer a terse response. 0.33. What is the ratio of the Aid flow (current US$) of Argentina in 2002 to that in 2005?
Provide a short and direct response. 1.17. What is the ratio of the Aid flow (current US$) in Cameroon in 2002 to that in 2005?
Give a very brief answer. 0.39. What is the ratio of the Aid flow (current US$) in Yemen, Rep. in 2002 to that in 2005?
Ensure brevity in your answer.  0.71. What is the ratio of the Aid flow (current US$) in Argentina in 2002 to that in 2006?
Your answer should be compact. 1.61. What is the ratio of the Aid flow (current US$) of Cameroon in 2002 to that in 2006?
Provide a short and direct response. 0.4. What is the ratio of the Aid flow (current US$) of Yemen, Rep. in 2002 to that in 2006?
Provide a succinct answer. 1.08. What is the ratio of the Aid flow (current US$) of Argentina in 2002 to that in 2007?
Offer a very short reply. 0.85. What is the ratio of the Aid flow (current US$) in Cameroon in 2002 to that in 2007?
Your answer should be very brief. 0.4. What is the ratio of the Aid flow (current US$) of Yemen, Rep. in 2002 to that in 2007?
Your answer should be compact. 0.61. What is the ratio of the Aid flow (current US$) of Argentina in 2002 to that in 2008?
Provide a succinct answer. 2.19. What is the ratio of the Aid flow (current US$) in Cameroon in 2002 to that in 2008?
Offer a terse response. 0.48. What is the ratio of the Aid flow (current US$) of Yemen, Rep. in 2002 to that in 2008?
Provide a short and direct response. 0.5. What is the ratio of the Aid flow (current US$) of Argentina in 2003 to that in 2004?
Make the answer very short. 1.25. What is the ratio of the Aid flow (current US$) in Cameroon in 2003 to that in 2004?
Your response must be concise. 0.64. What is the ratio of the Aid flow (current US$) of Yemen, Rep. in 2003 to that in 2004?
Keep it short and to the point. 1.35. What is the ratio of the Aid flow (current US$) in Argentina in 2003 to that in 2005?
Your answer should be very brief. 1.06. What is the ratio of the Aid flow (current US$) in Cameroon in 2003 to that in 2005?
Ensure brevity in your answer.  0.56. What is the ratio of the Aid flow (current US$) of Yemen, Rep. in 2003 to that in 2005?
Provide a short and direct response. 2.91. What is the ratio of the Aid flow (current US$) in Argentina in 2003 to that in 2006?
Make the answer very short. 1.45. What is the ratio of the Aid flow (current US$) of Cameroon in 2003 to that in 2006?
Ensure brevity in your answer.  0.57. What is the ratio of the Aid flow (current US$) of Yemen, Rep. in 2003 to that in 2006?
Offer a very short reply. 4.42. What is the ratio of the Aid flow (current US$) in Argentina in 2003 to that in 2007?
Offer a very short reply. 0.77. What is the ratio of the Aid flow (current US$) in Cameroon in 2003 to that in 2007?
Offer a terse response. 0.58. What is the ratio of the Aid flow (current US$) of Yemen, Rep. in 2003 to that in 2007?
Provide a short and direct response. 2.5. What is the ratio of the Aid flow (current US$) in Argentina in 2003 to that in 2008?
Your response must be concise. 1.97. What is the ratio of the Aid flow (current US$) of Cameroon in 2003 to that in 2008?
Your answer should be compact. 0.69. What is the ratio of the Aid flow (current US$) in Yemen, Rep. in 2003 to that in 2008?
Provide a succinct answer. 2.04. What is the ratio of the Aid flow (current US$) in Argentina in 2004 to that in 2005?
Provide a short and direct response. 0.84. What is the ratio of the Aid flow (current US$) in Cameroon in 2004 to that in 2005?
Your answer should be compact. 0.87. What is the ratio of the Aid flow (current US$) of Yemen, Rep. in 2004 to that in 2005?
Ensure brevity in your answer.  2.15. What is the ratio of the Aid flow (current US$) of Argentina in 2004 to that in 2006?
Provide a short and direct response. 1.16. What is the ratio of the Aid flow (current US$) in Cameroon in 2004 to that in 2006?
Ensure brevity in your answer.  0.9. What is the ratio of the Aid flow (current US$) of Yemen, Rep. in 2004 to that in 2006?
Give a very brief answer. 3.28. What is the ratio of the Aid flow (current US$) in Argentina in 2004 to that in 2007?
Give a very brief answer. 0.61. What is the ratio of the Aid flow (current US$) in Cameroon in 2004 to that in 2007?
Ensure brevity in your answer.  0.91. What is the ratio of the Aid flow (current US$) of Yemen, Rep. in 2004 to that in 2007?
Give a very brief answer. 1.85. What is the ratio of the Aid flow (current US$) in Argentina in 2004 to that in 2008?
Give a very brief answer. 1.57. What is the ratio of the Aid flow (current US$) of Cameroon in 2004 to that in 2008?
Give a very brief answer. 1.08. What is the ratio of the Aid flow (current US$) in Yemen, Rep. in 2004 to that in 2008?
Make the answer very short. 1.51. What is the ratio of the Aid flow (current US$) in Argentina in 2005 to that in 2006?
Provide a short and direct response. 1.37. What is the ratio of the Aid flow (current US$) of Cameroon in 2005 to that in 2006?
Give a very brief answer. 1.03. What is the ratio of the Aid flow (current US$) of Yemen, Rep. in 2005 to that in 2006?
Keep it short and to the point. 1.52. What is the ratio of the Aid flow (current US$) in Argentina in 2005 to that in 2007?
Ensure brevity in your answer.  0.73. What is the ratio of the Aid flow (current US$) in Cameroon in 2005 to that in 2007?
Offer a very short reply. 1.04. What is the ratio of the Aid flow (current US$) of Yemen, Rep. in 2005 to that in 2007?
Keep it short and to the point. 0.86. What is the ratio of the Aid flow (current US$) of Argentina in 2005 to that in 2008?
Offer a terse response. 1.86. What is the ratio of the Aid flow (current US$) of Cameroon in 2005 to that in 2008?
Your answer should be very brief. 1.24. What is the ratio of the Aid flow (current US$) of Yemen, Rep. in 2005 to that in 2008?
Offer a very short reply. 0.7. What is the ratio of the Aid flow (current US$) in OECD members in 2006 to that in 2007?
Give a very brief answer. 1.83. What is the ratio of the Aid flow (current US$) in Argentina in 2006 to that in 2007?
Provide a succinct answer. 0.53. What is the ratio of the Aid flow (current US$) in Cameroon in 2006 to that in 2007?
Ensure brevity in your answer.  1.01. What is the ratio of the Aid flow (current US$) of Yemen, Rep. in 2006 to that in 2007?
Give a very brief answer. 0.57. What is the ratio of the Aid flow (current US$) in OECD members in 2006 to that in 2008?
Offer a terse response. 0.39. What is the ratio of the Aid flow (current US$) of Argentina in 2006 to that in 2008?
Offer a very short reply. 1.36. What is the ratio of the Aid flow (current US$) of Cameroon in 2006 to that in 2008?
Ensure brevity in your answer.  1.2. What is the ratio of the Aid flow (current US$) in Yemen, Rep. in 2006 to that in 2008?
Keep it short and to the point. 0.46. What is the ratio of the Aid flow (current US$) in OECD members in 2007 to that in 2008?
Your response must be concise. 0.21. What is the ratio of the Aid flow (current US$) in Argentina in 2007 to that in 2008?
Your response must be concise. 2.56. What is the ratio of the Aid flow (current US$) of Cameroon in 2007 to that in 2008?
Your answer should be compact. 1.19. What is the ratio of the Aid flow (current US$) of Yemen, Rep. in 2007 to that in 2008?
Your response must be concise. 0.82. What is the difference between the highest and the second highest Aid flow (current US$) in OECD members?
Make the answer very short. 1.46e+08. What is the difference between the highest and the second highest Aid flow (current US$) in Argentina?
Provide a succinct answer. 1.42e+06. What is the difference between the highest and the second highest Aid flow (current US$) in Cameroon?
Make the answer very short. 2.20e+07. What is the difference between the highest and the second highest Aid flow (current US$) of Yemen, Rep.?
Your response must be concise. 6.36e+06. What is the difference between the highest and the lowest Aid flow (current US$) in OECD members?
Give a very brief answer. 2.38e+08. What is the difference between the highest and the lowest Aid flow (current US$) of Argentina?
Offer a terse response. 1.06e+07. What is the difference between the highest and the lowest Aid flow (current US$) of Cameroon?
Offer a terse response. 3.38e+07. What is the difference between the highest and the lowest Aid flow (current US$) in Yemen, Rep.?
Your answer should be compact. 1.96e+07. 